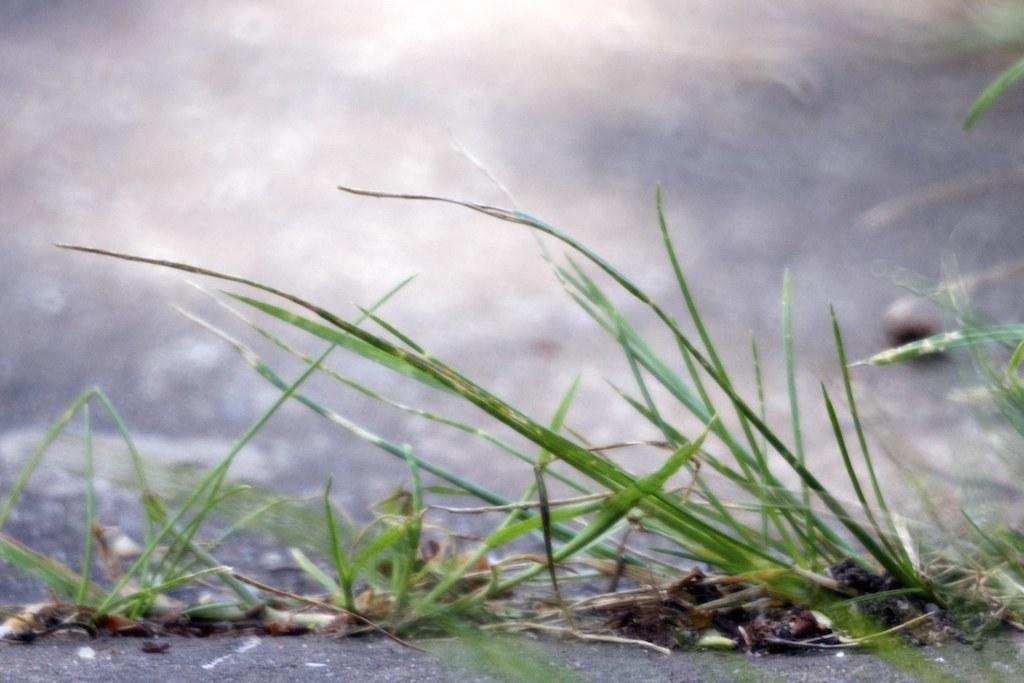What type of vegetation is present on the ground in the image? There is grass on the ground in the image. How many flowers are visible in the image? There are no flowers visible in the image; only grass is present on the ground. What type of boats can be seen sailing in the image? There are no boats present in the image; it only features grass on the ground. 